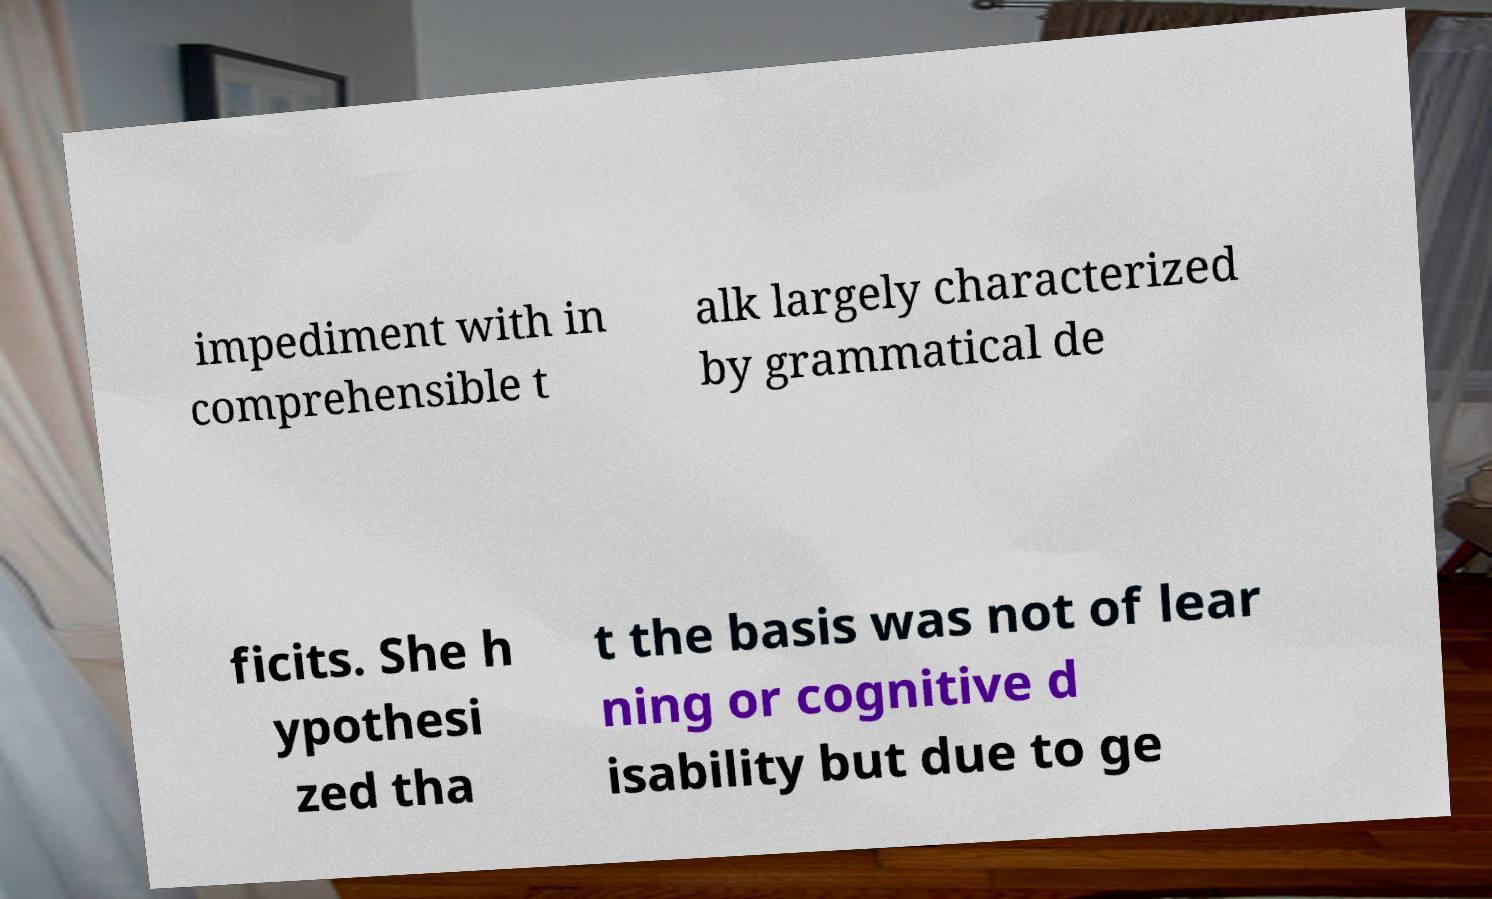Please identify and transcribe the text found in this image. impediment with in comprehensible t alk largely characterized by grammatical de ficits. She h ypothesi zed tha t the basis was not of lear ning or cognitive d isability but due to ge 